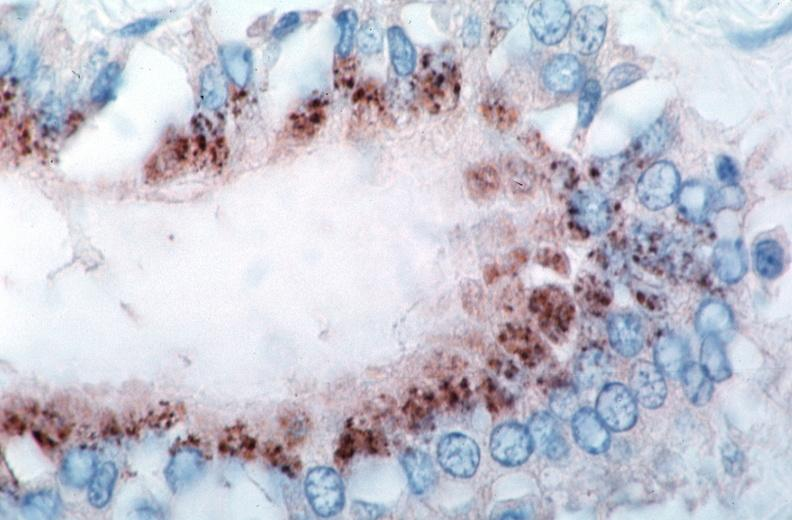s vasculature present?
Answer the question using a single word or phrase. Yes 